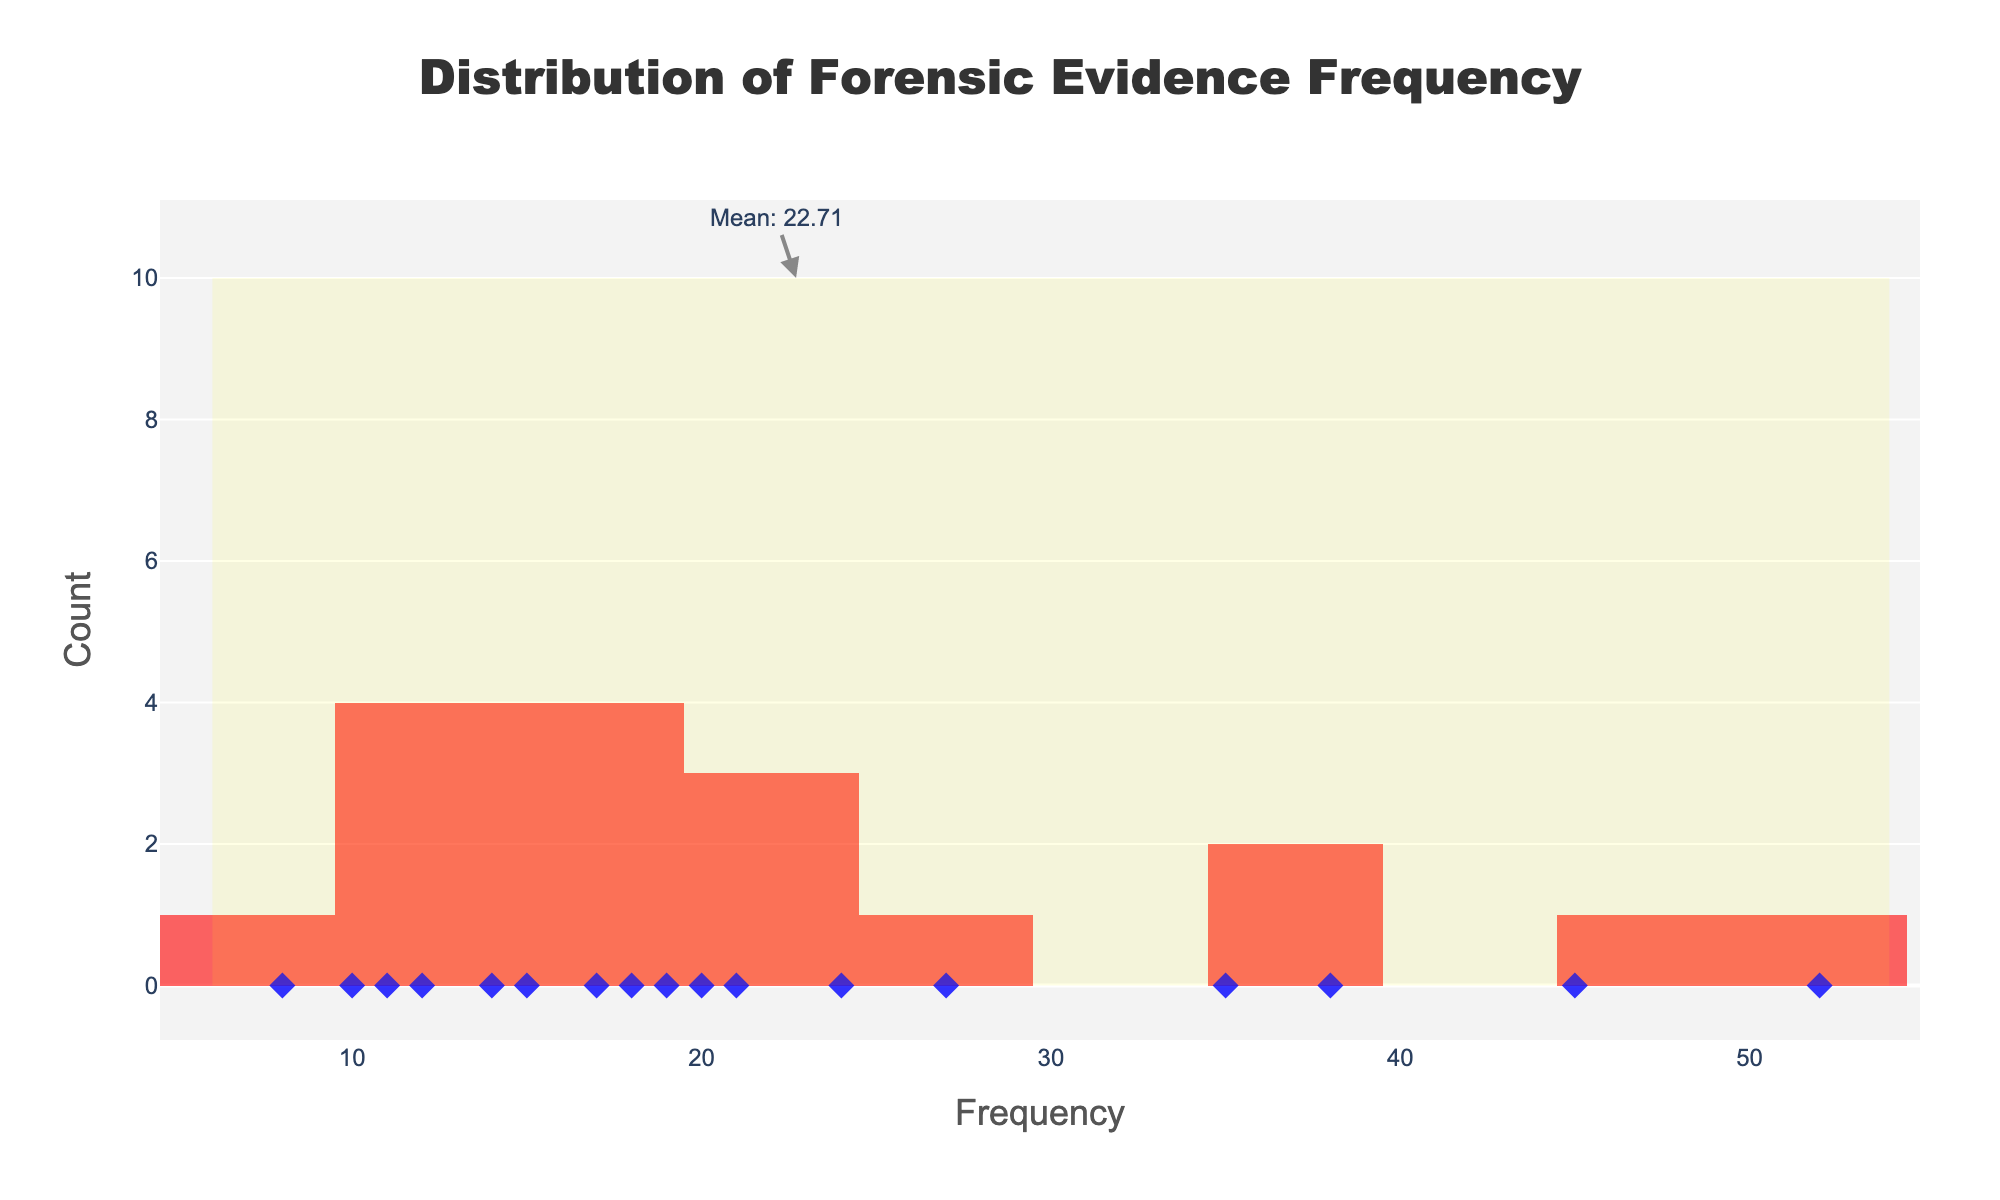what is the title of the plot? The title is written at the top of the figure and usually provides a summary of what the plot represents. Here, the title says "Distribution of Forensic Evidence Frequency".
Answer: Distribution of Forensic Evidence Frequency what does the x-axis represent? The axis label at the bottom indicates what the values on the horizontal axis stand for. Here, the x-axis is labeled as "Frequency".
Answer: Frequency how many evidence types have a frequency higher than 40? To find out the number of evidence types with frequencies above 40, look at the x-axis values above 40 and count the corresponding occurrences. There are two: 'Blood Stains' (45) and 'Fingerprints' (52).
Answer: 2 what is the shape of the markers used for individual data points? The markers indicate individual data points and their shapes help in identifying them. Here, the markers are described as 'diamond' shapes in the plot.
Answer: Diamond which evidence type has the highest frequency? By looking at the highest value on the x-axis with a corresponding bar, we see that 'Fingerprints' has the highest frequency, which is 52.
Answer: Fingerprints which evidence type has the lowest frequency? By observing the smallest bar on the x-axis, we see that 'Vomit' has the lowest frequency, which is 8.
Answer: Vomit what is the mean frequency of the evidence types? The plot has an annotation pointing to the mean frequency which also includes the computed value. The mean is indicated at the 10 y-axis mark with text "Mean: 23.35".
Answer: 23.35 how many bins are set in the histogram? To find the number of bins, one can count the divisions for the bars along the x-axis. Here, the number of bins is set to be 15 according to the code, and we can also visually see the separation between the bars.
Answer: 15 which color represents the histogram bars, and which for the data points? The histogram bars are described as red with an opacity (i.e., slightly transparent red), while the data points are blue diamond markers. This description is a visual summary of marker and bar colors.
Answer: Histogram bars are red; data points are blue 